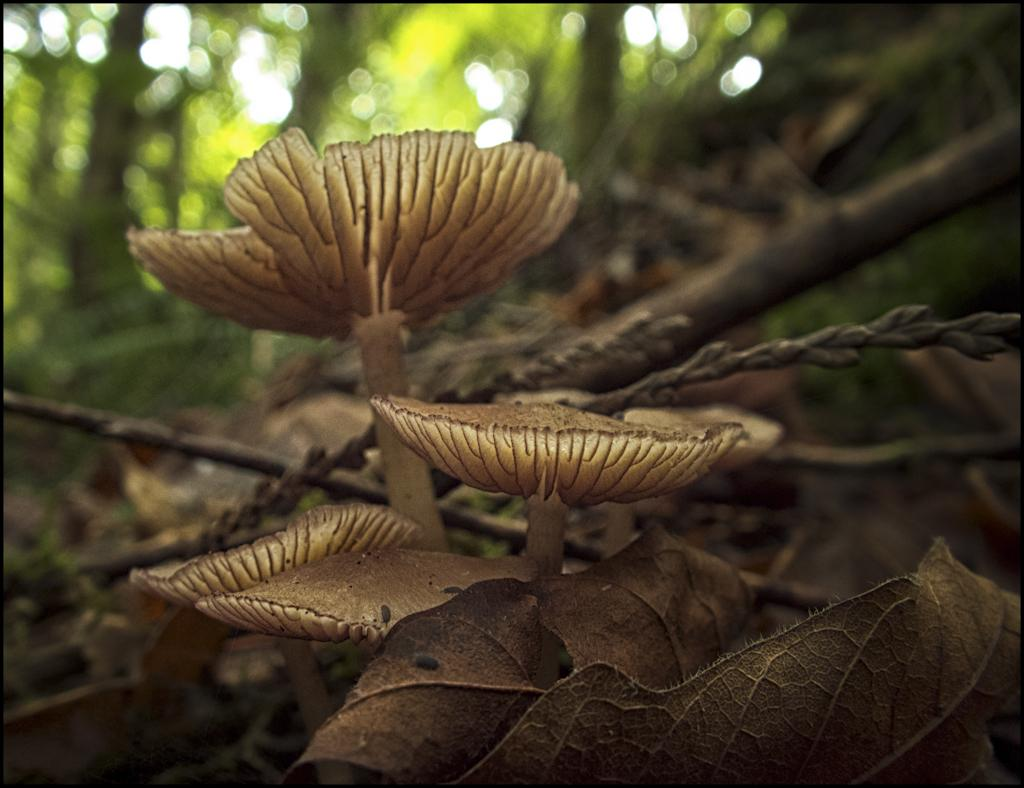What type of fungi can be seen in the image? There are mushrooms in the image. What can be found on the ground in the image? There are leaves on the ground in the image. What is visible in the background of the image? There are trees visible in the background of the image. What type of iron is being used to select the mushrooms in the image? There is no iron or selection process depicted in the image; it simply shows mushrooms, leaves, and trees. 